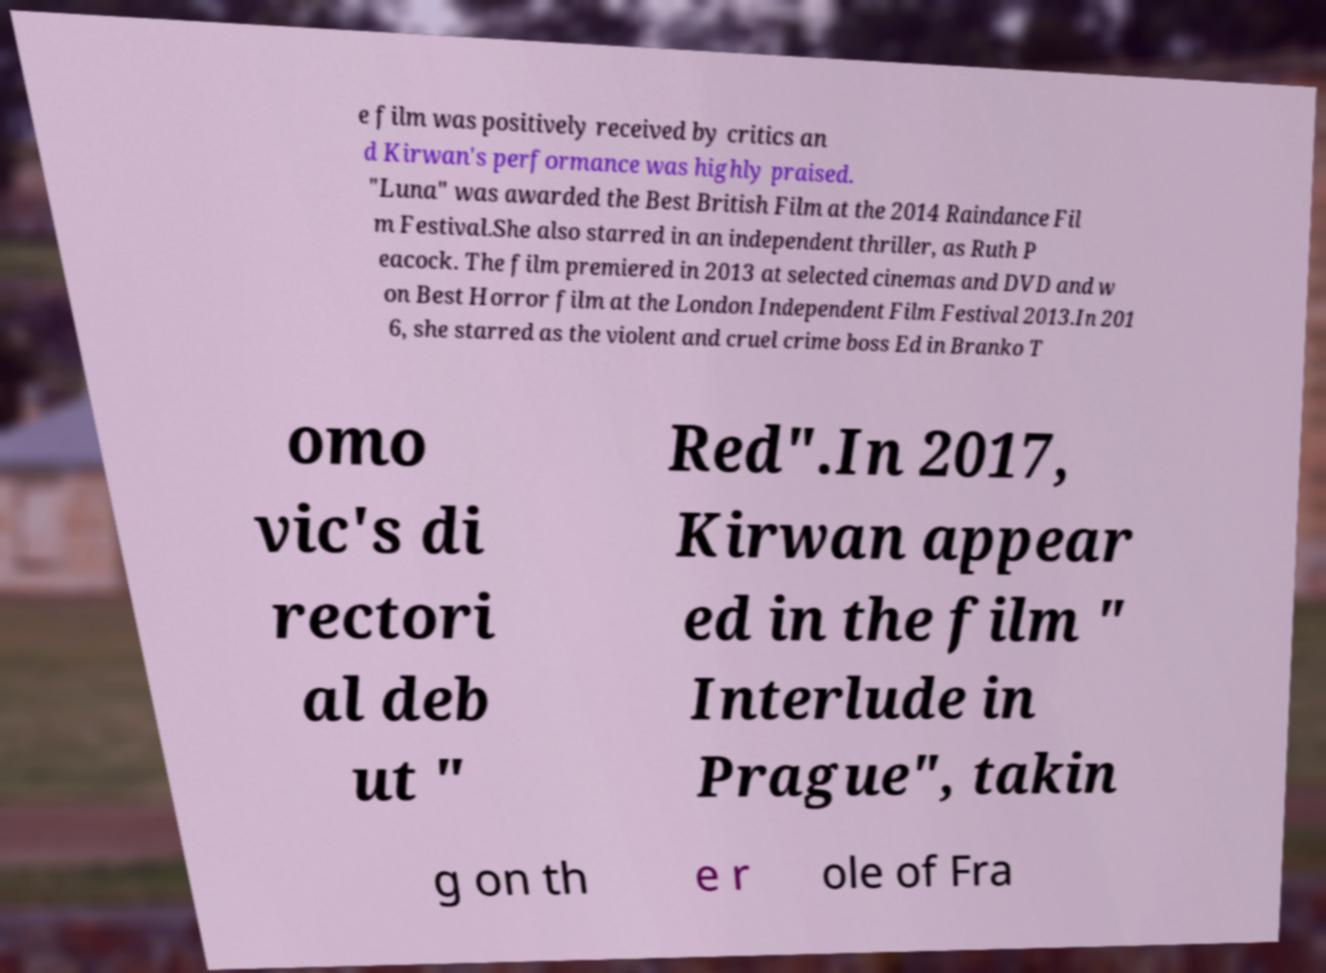Can you accurately transcribe the text from the provided image for me? e film was positively received by critics an d Kirwan's performance was highly praised. "Luna" was awarded the Best British Film at the 2014 Raindance Fil m Festival.She also starred in an independent thriller, as Ruth P eacock. The film premiered in 2013 at selected cinemas and DVD and w on Best Horror film at the London Independent Film Festival 2013.In 201 6, she starred as the violent and cruel crime boss Ed in Branko T omo vic's di rectori al deb ut " Red".In 2017, Kirwan appear ed in the film " Interlude in Prague", takin g on th e r ole of Fra 